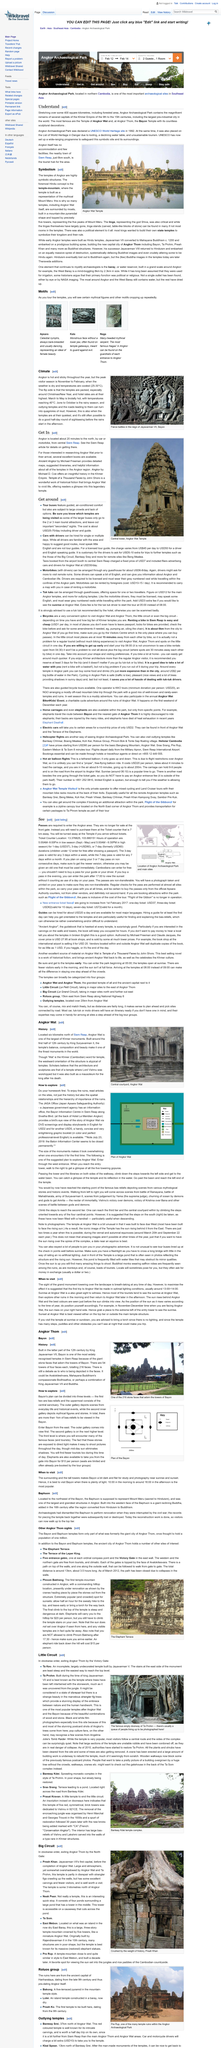Draw attention to some important aspects in this diagram. Angkor Wat is one of the finest monuments in the world. What is a recommended fiction book about Angkor Wat?" Temple of a Thousand Faces by John Shors is a highly acclaimed historical fiction novel that vividly depicts the majesty of Angkor Wat and transports readers to the ancient kingdom of Cambodia. Angkor, a famous archaeological site in Cambodia, is located approximately 20 minutes north of the central city of Siem Reap via car or motorbike. Angkor Wat, which was constructed during the first half of the 12th century, is a part of its history. Angkor Wat, a historical temple complex located six kilometres north of Siem Reap, is known for its stunning architecture and historical significance. 